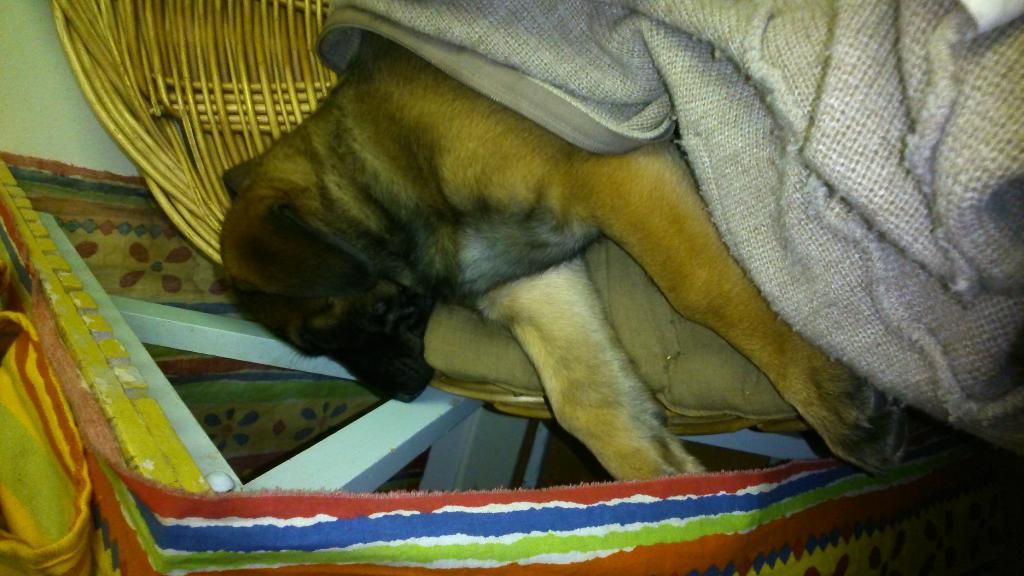Describe this image in one or two sentences. In the image there is a dog laying in a basket with a blanket above it and beside it there is a table with a cloth on it. 